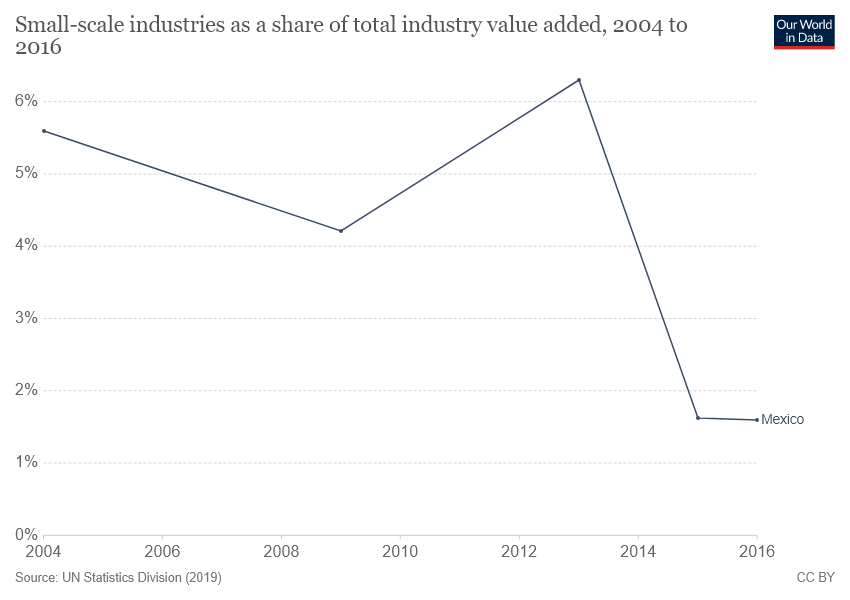Point out several critical features in this image. The line chart represents the country of Mexico. The year that the unemployment rate crossed 6% was 2013. 